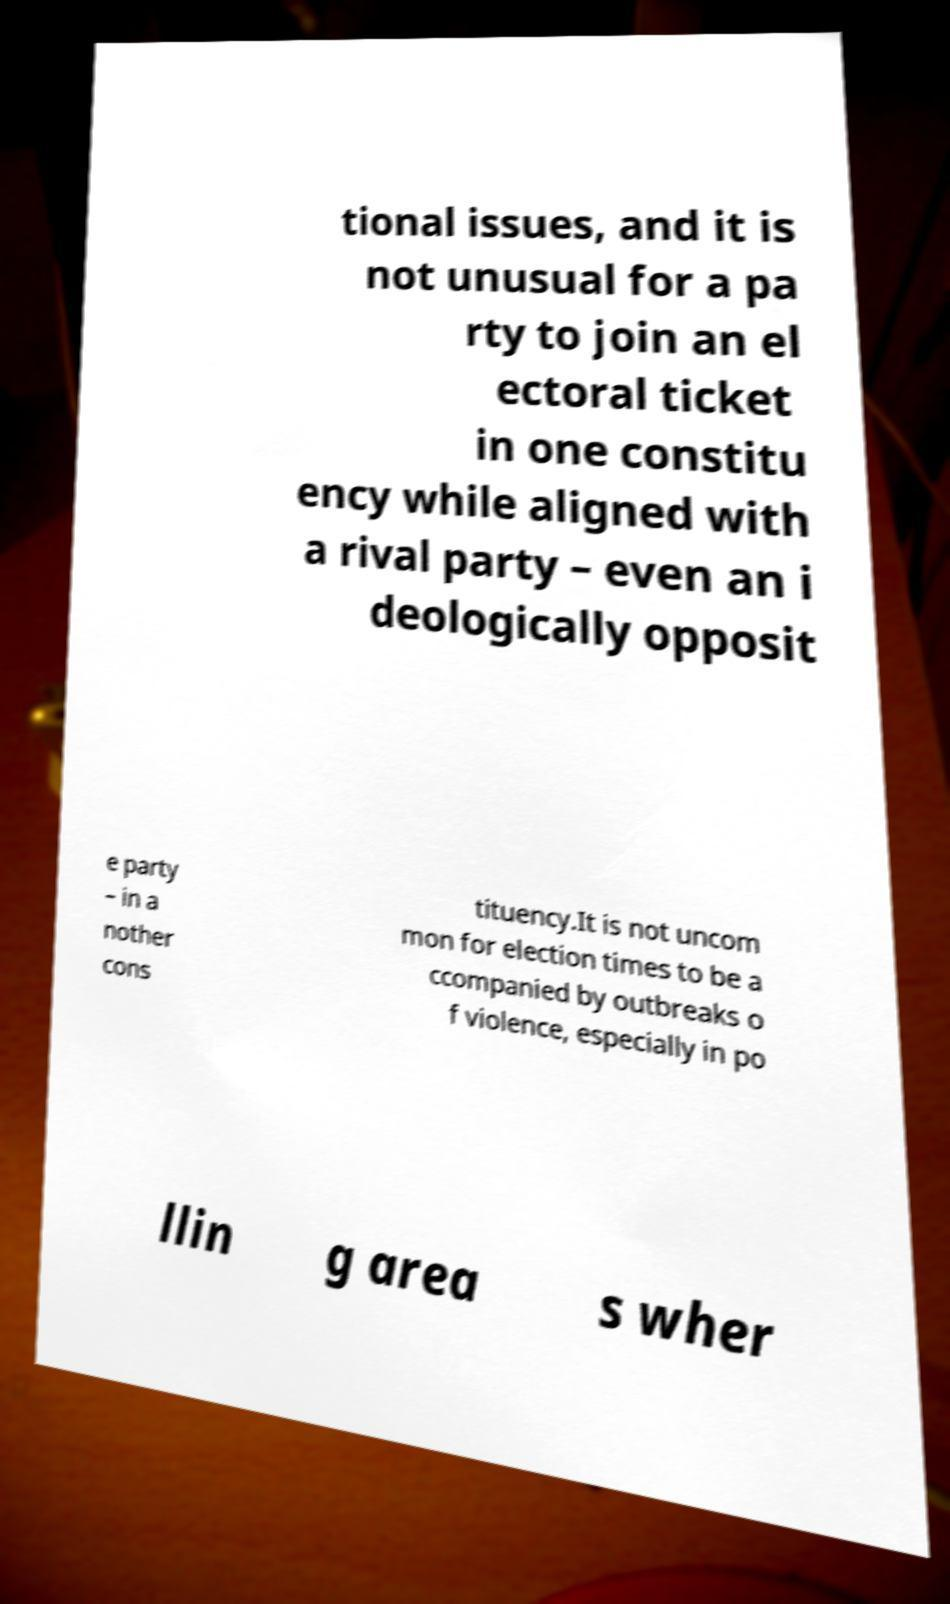Please read and relay the text visible in this image. What does it say? tional issues, and it is not unusual for a pa rty to join an el ectoral ticket in one constitu ency while aligned with a rival party – even an i deologically opposit e party – in a nother cons tituency.It is not uncom mon for election times to be a ccompanied by outbreaks o f violence, especially in po llin g area s wher 